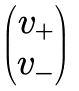<formula> <loc_0><loc_0><loc_500><loc_500>\begin{pmatrix} v _ { + } \\ v _ { - } \end{pmatrix}</formula> 